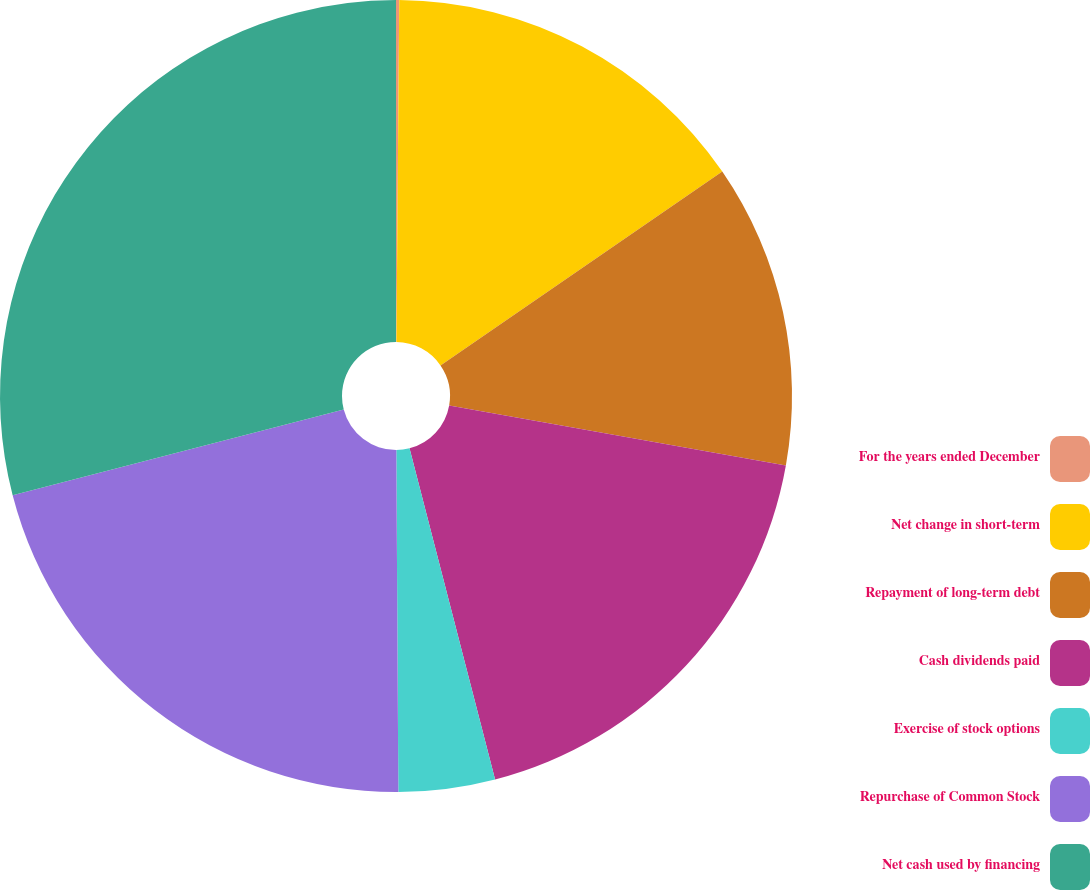Convert chart to OTSL. <chart><loc_0><loc_0><loc_500><loc_500><pie_chart><fcel>For the years ended December<fcel>Net change in short-term<fcel>Repayment of long-term debt<fcel>Cash dividends paid<fcel>Exercise of stock options<fcel>Repurchase of Common Stock<fcel>Net cash used by financing<nl><fcel>0.13%<fcel>15.28%<fcel>12.39%<fcel>18.17%<fcel>3.93%<fcel>21.06%<fcel>29.03%<nl></chart> 